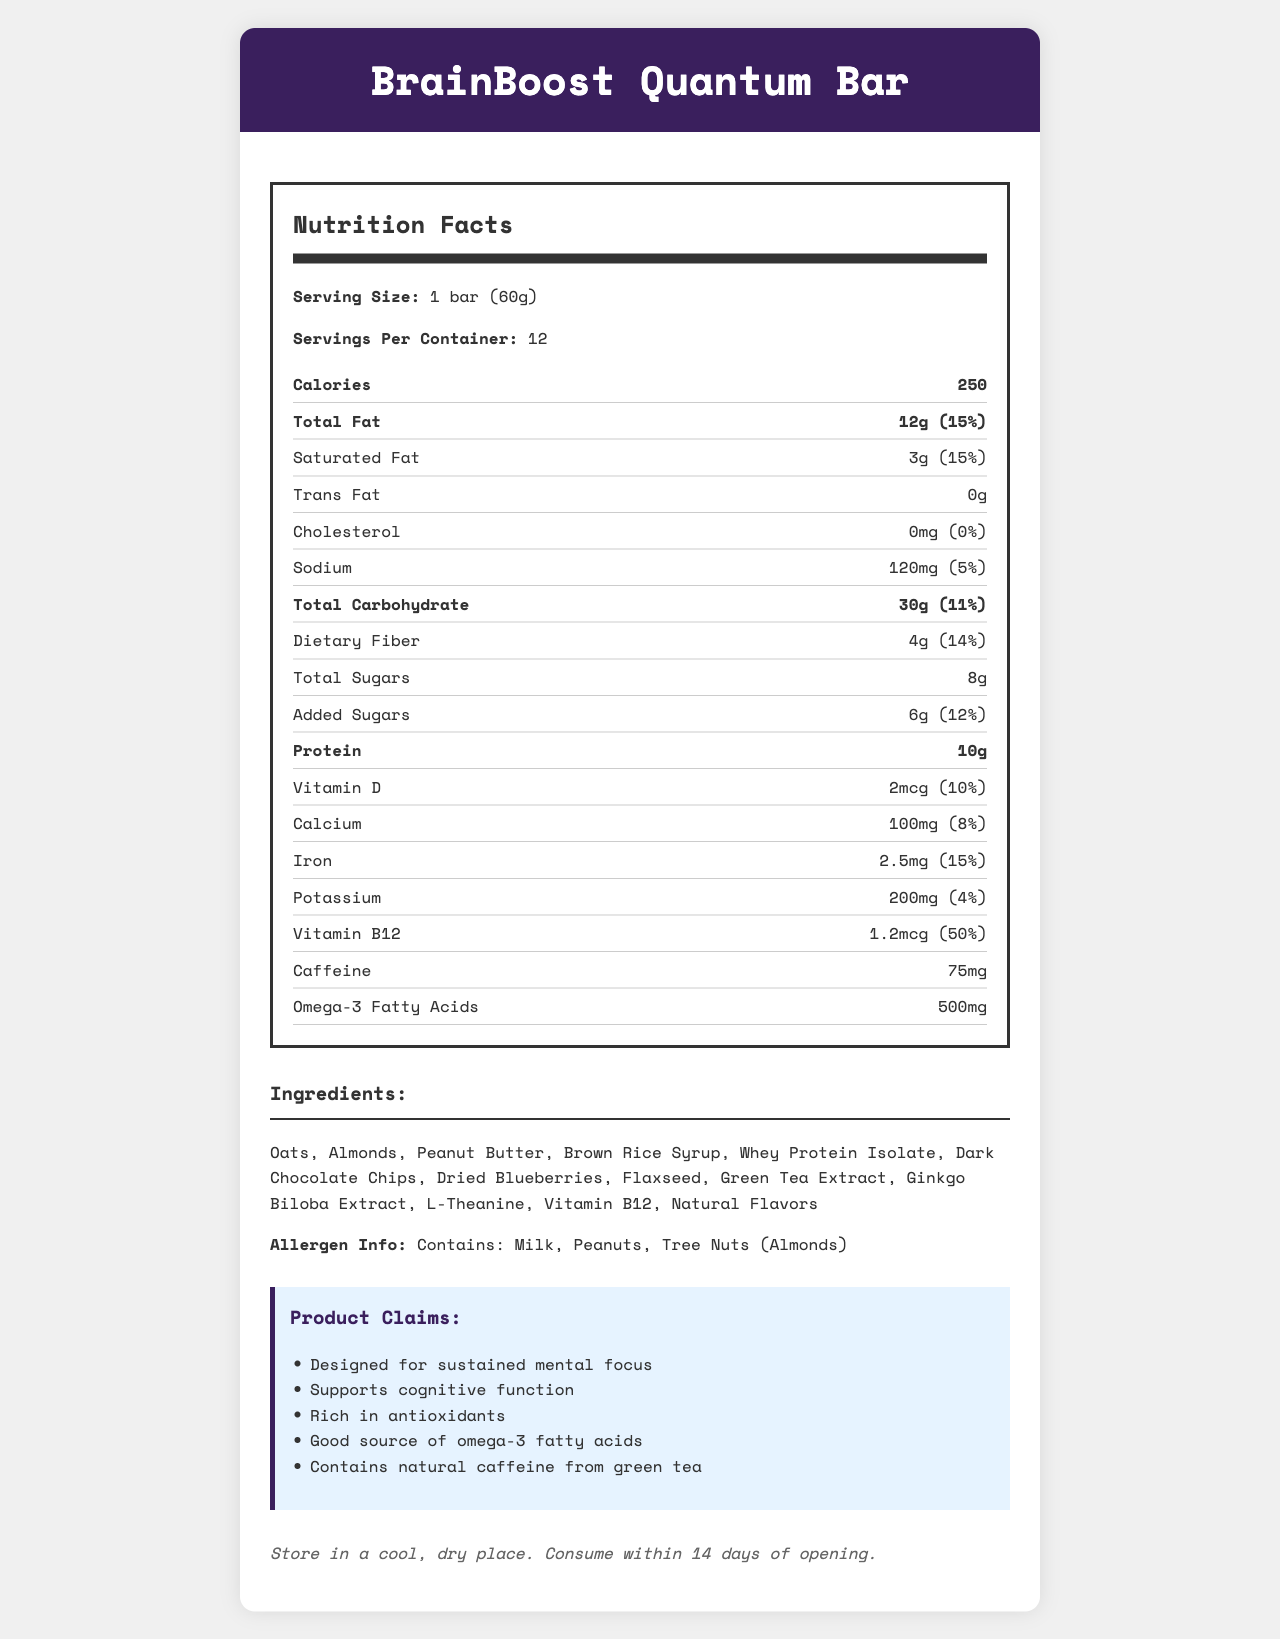what is the serving size of BrainBoost Quantum Bar? The serving size is clearly stated as "1 bar (60g)" in the document.
Answer: 1 bar (60g) how many calories does one serving of BrainBoost Quantum Bar contain? The document specifies that one serving contains 250 calories.
Answer: 250 how much saturated fat is in a serving? The document lists the amount of saturated fat as "3g".
Answer: 3g how much protein is present in one bar? According to the document, one bar contains 10g of protein.
Answer: 10g what are the main ingredients of the BrainBoost Quantum Bar? The document lists all the ingredients under the "Ingredients" section.
Answer: Oats, Almonds, Peanut Butter, Brown Rice Syrup, Whey Protein Isolate, Dark Chocolate Chips, Dried Blueberries, Flaxseed, Green Tea Extract, Ginkgo Biloba Extract, L-Theanine, Vitamin B12, Natural Flavors what percentage of the daily value of Vitamin B12 does one serving provide? The daily value percentage for Vitamin B12 is stated as 50% in the document.
Answer: 50% which ingredient is the primary source of protein in the bar? A. Oats B. Peanut Butter C. Whey Protein Isolate D. Flaxseed Whey Protein Isolate is mentioned in the ingredient list and is a common primary source of protein.
Answer: C. Whey Protein Isolate how many milligrams of sodium are in one bar? The amount of sodium per serving is listed as "120mg" in the document.
Answer: 120mg which of the following claims is made about the product? I. Supports cognitive function II. Low in sugar III. Contains added vitamins IV. High in fiber The claims mentioned in the document include "Supports cognitive function" and "Rich in antioxidants", "Contains natural caffeine from green tea," but not “Low in sugar” or “High in fiber.”
Answer: I, III does the BrainBoost Quantum Bar contain any trans fat? The amount of trans fat is listed as "0g" in the document.
Answer: No what allergy warnings are provided for this product? The allergen information clearly states that the product contains milk, peanuts, and tree nuts (almonds).
Answer: Contains: Milk, Peanuts, Tree Nuts (Almonds) what is the main idea of the BrainBoost Quantum Bar's nutritional profile? The document emphasizes the bar's nutritional benefits like sustained mental focus, support for cognitive function, and its rich antioxidant properties, along with detailed nutritional information.
Answer: The BrainBoost Quantum Bar is designed as a high-energy snack that supports mental focus and cognitive function. It contains moderate calories, healthy fats, protein, and added nutrients, including omega-3 fatty acids and vitamin B12. It also includes natural caffeine for sustained energy. how many servings are included in one container of BrainBoost Quantum Bar? The document specifies that there are 12 servings per container.
Answer: 12 what is the storage instruction for this product? The storage instructions are clearly stated at the end of the document.
Answer: Store in a cool, dry place. Consume within 14 days of opening. Can I determine how long the bar can be stored before opening from this document? The document only specifies storage instructions after opening, not before.
Answer: Not enough information 